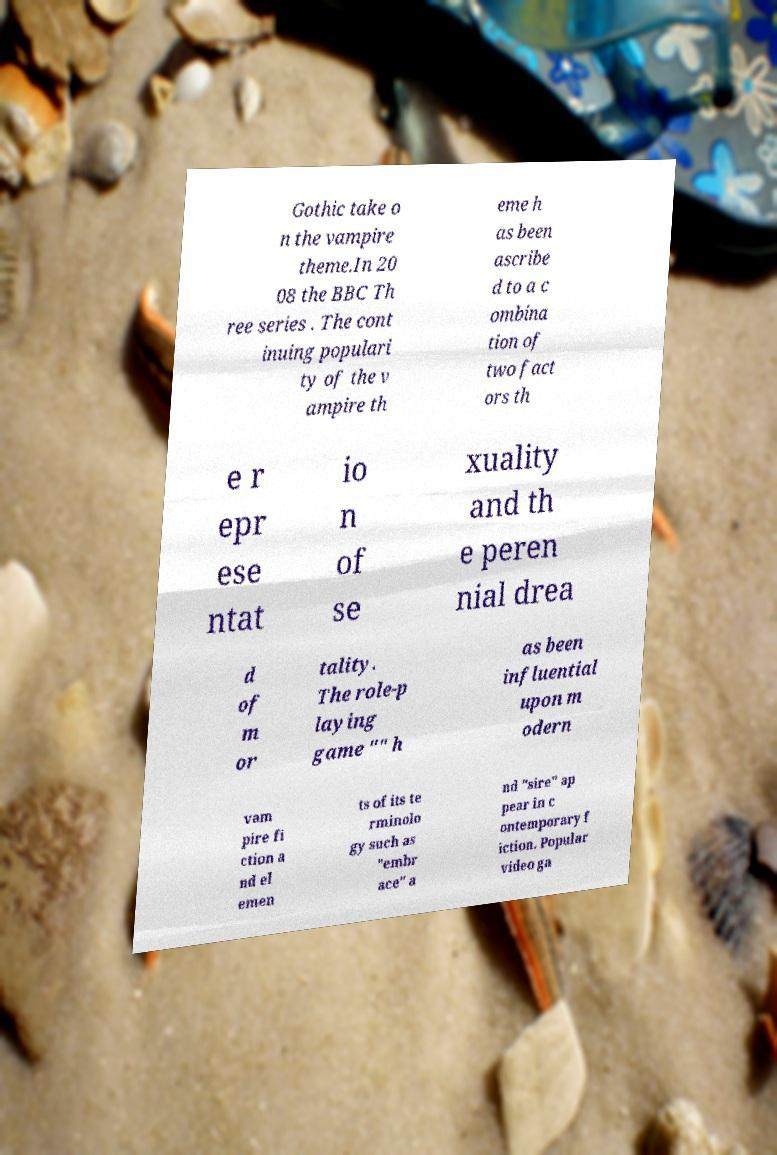Please read and relay the text visible in this image. What does it say? Gothic take o n the vampire theme.In 20 08 the BBC Th ree series . The cont inuing populari ty of the v ampire th eme h as been ascribe d to a c ombina tion of two fact ors th e r epr ese ntat io n of se xuality and th e peren nial drea d of m or tality. The role-p laying game "" h as been influential upon m odern vam pire fi ction a nd el emen ts of its te rminolo gy such as "embr ace" a nd "sire" ap pear in c ontemporary f iction. Popular video ga 